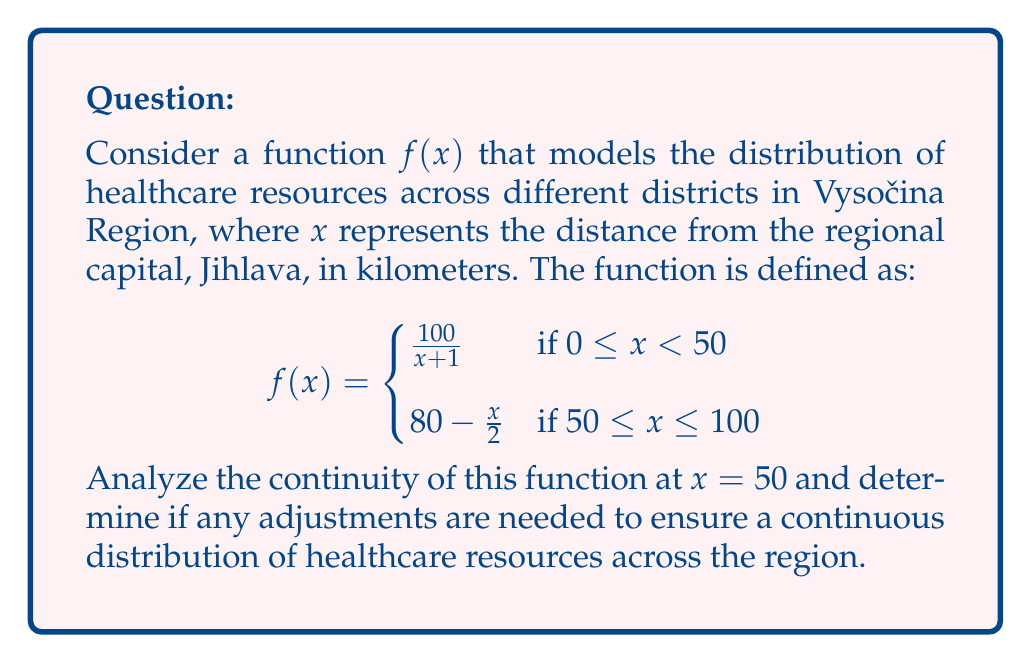Provide a solution to this math problem. To analyze the continuity of the function at $x = 50$, we need to check if the following three conditions are met:

1. $f(50)$ is defined
2. $\lim_{x \to 50^-} f(x)$ exists
3. $\lim_{x \to 50^+} f(x)$ exists
4. $\lim_{x \to 50^-} f(x) = \lim_{x \to 50^+} f(x) = f(50)$

Step 1: Check if $f(50)$ is defined
$f(50)$ is defined in the second piece of the function:
$f(50) = 80 - \frac{50}{2} = 55$

Step 2: Calculate $\lim_{x \to 50^-} f(x)$
$$\lim_{x \to 50^-} f(x) = \lim_{x \to 50^-} \frac{100}{x+1} = \frac{100}{51} \approx 1.9608$$

Step 3: Calculate $\lim_{x \to 50^+} f(x)$
$$\lim_{x \to 50^+} f(x) = \lim_{x \to 50^+} (80 - \frac{x}{2}) = 80 - \frac{50}{2} = 55$$

Step 4: Compare the limits and $f(50)$
We can see that:
$\lim_{x \to 50^-} f(x) \approx 1.9608$
$\lim_{x \to 50^+} f(x) = 55$
$f(50) = 55$

Since $\lim_{x \to 50^-} f(x) \neq \lim_{x \to 50^+} f(x)$, the function is not continuous at $x = 50$.

To ensure a continuous distribution of healthcare resources, we need to adjust the function. One way to do this is to modify the first piece of the function to match the second piece at $x = 50$:

$$f(x) = \begin{cases}
\frac{2750}{x+1} & \text{if } 0 \leq x < 50 \\
80 - \frac{x}{2} & \text{if } 50 \leq x \leq 100
\end{cases}$$

Now, $\lim_{x \to 50^-} f(x) = \frac{2750}{51} = 55$, which matches $\lim_{x \to 50^+} f(x)$ and $f(50)$, ensuring continuity at $x = 50$.
Answer: The function is not continuous at $x = 50$. Adjusting the first piece to $\frac{2750}{x+1}$ ensures continuity. 